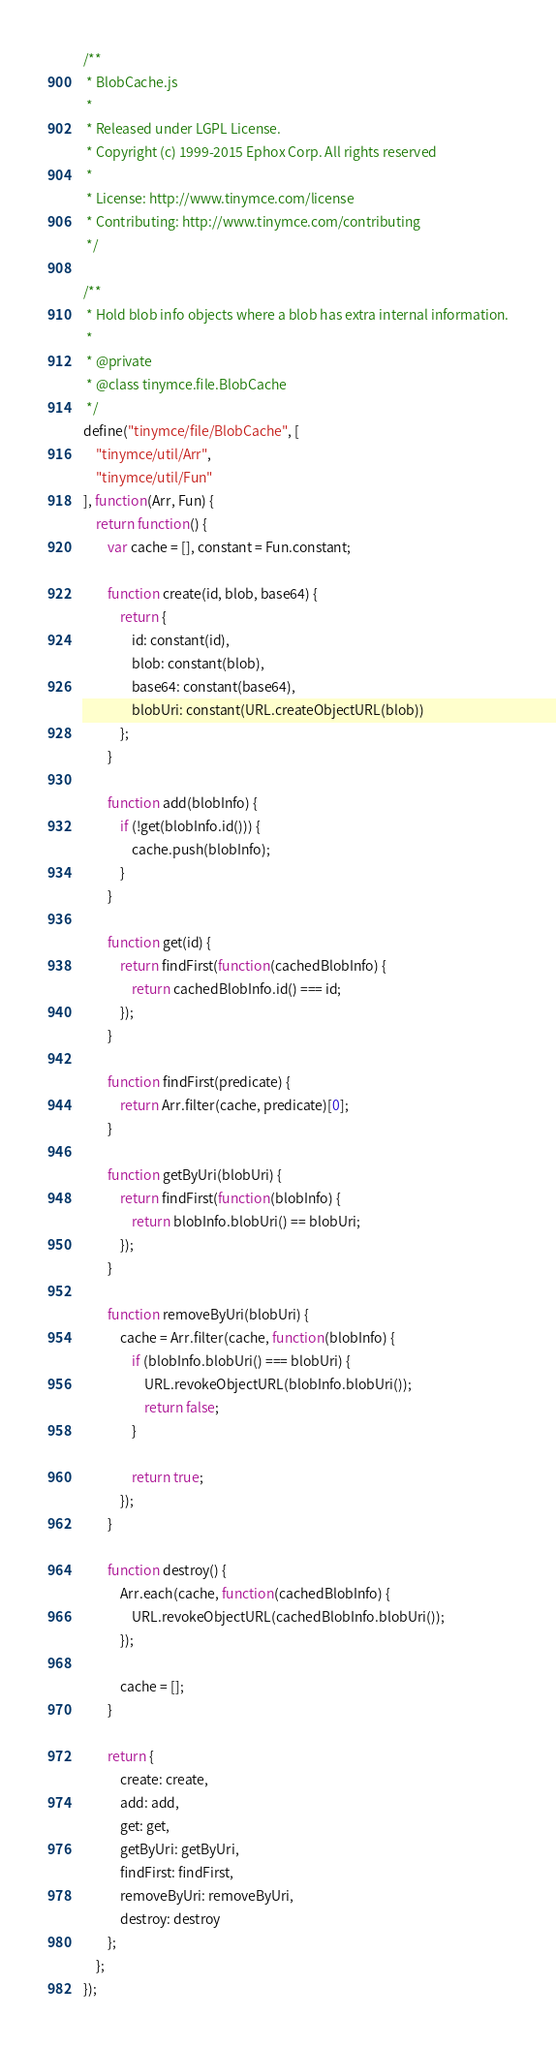<code> <loc_0><loc_0><loc_500><loc_500><_JavaScript_>/**
 * BlobCache.js
 *
 * Released under LGPL License.
 * Copyright (c) 1999-2015 Ephox Corp. All rights reserved
 *
 * License: http://www.tinymce.com/license
 * Contributing: http://www.tinymce.com/contributing
 */

/**
 * Hold blob info objects where a blob has extra internal information.
 *
 * @private
 * @class tinymce.file.BlobCache
 */
define("tinymce/file/BlobCache", [
	"tinymce/util/Arr",
	"tinymce/util/Fun"
], function(Arr, Fun) {
	return function() {
		var cache = [], constant = Fun.constant;

		function create(id, blob, base64) {
			return {
				id: constant(id),
				blob: constant(blob),
				base64: constant(base64),
				blobUri: constant(URL.createObjectURL(blob))
			};
		}

		function add(blobInfo) {
			if (!get(blobInfo.id())) {
				cache.push(blobInfo);
			}
		}

		function get(id) {
			return findFirst(function(cachedBlobInfo) {
				return cachedBlobInfo.id() === id;
			});
		}

		function findFirst(predicate) {
			return Arr.filter(cache, predicate)[0];
		}

		function getByUri(blobUri) {
			return findFirst(function(blobInfo) {
				return blobInfo.blobUri() == blobUri;
			});
		}

		function removeByUri(blobUri) {
			cache = Arr.filter(cache, function(blobInfo) {
				if (blobInfo.blobUri() === blobUri) {
					URL.revokeObjectURL(blobInfo.blobUri());
					return false;
				}

				return true;
			});
		}

		function destroy() {
			Arr.each(cache, function(cachedBlobInfo) {
				URL.revokeObjectURL(cachedBlobInfo.blobUri());
			});

			cache = [];
		}

		return {
			create: create,
			add: add,
			get: get,
			getByUri: getByUri,
			findFirst: findFirst,
			removeByUri: removeByUri,
			destroy: destroy
		};
	};
});</code> 